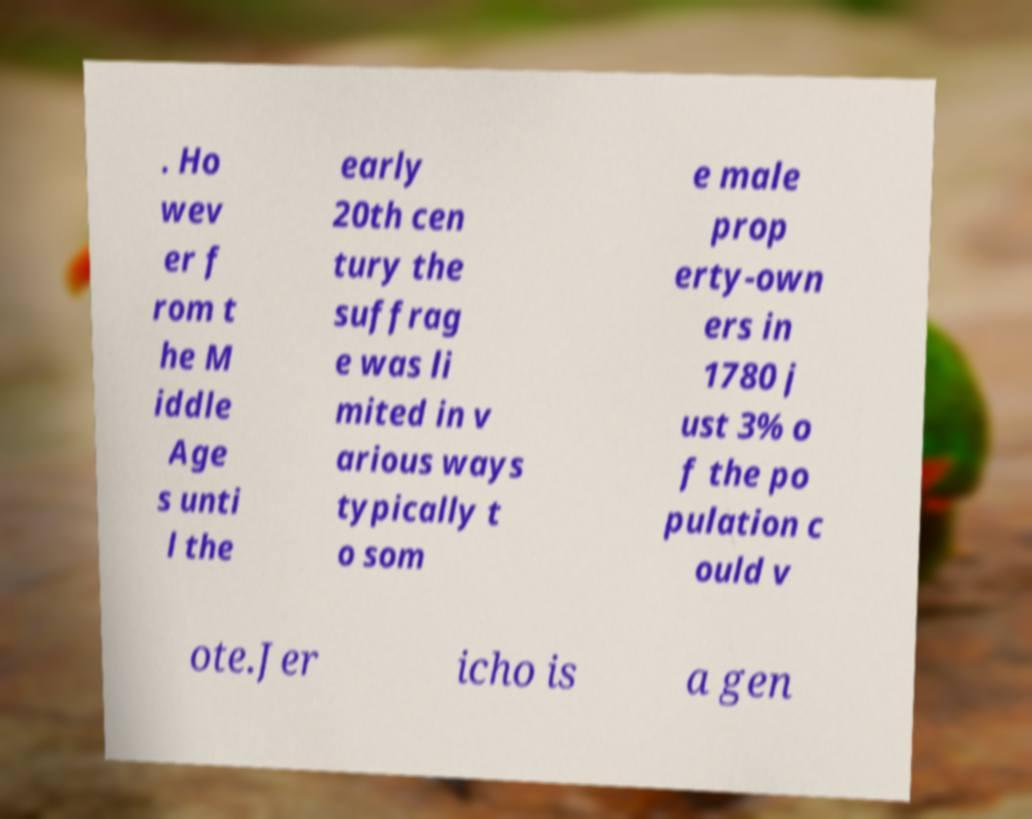I need the written content from this picture converted into text. Can you do that? . Ho wev er f rom t he M iddle Age s unti l the early 20th cen tury the suffrag e was li mited in v arious ways typically t o som e male prop erty-own ers in 1780 j ust 3% o f the po pulation c ould v ote.Jer icho is a gen 